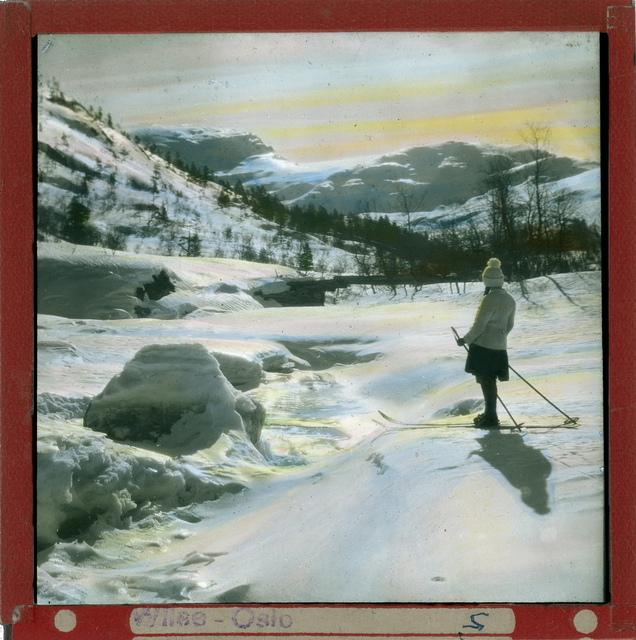What's the weather like?
Be succinct. Snowy. Is the woman wearing pants?
Concise answer only. No. Is this a painting?
Keep it brief. Yes. 